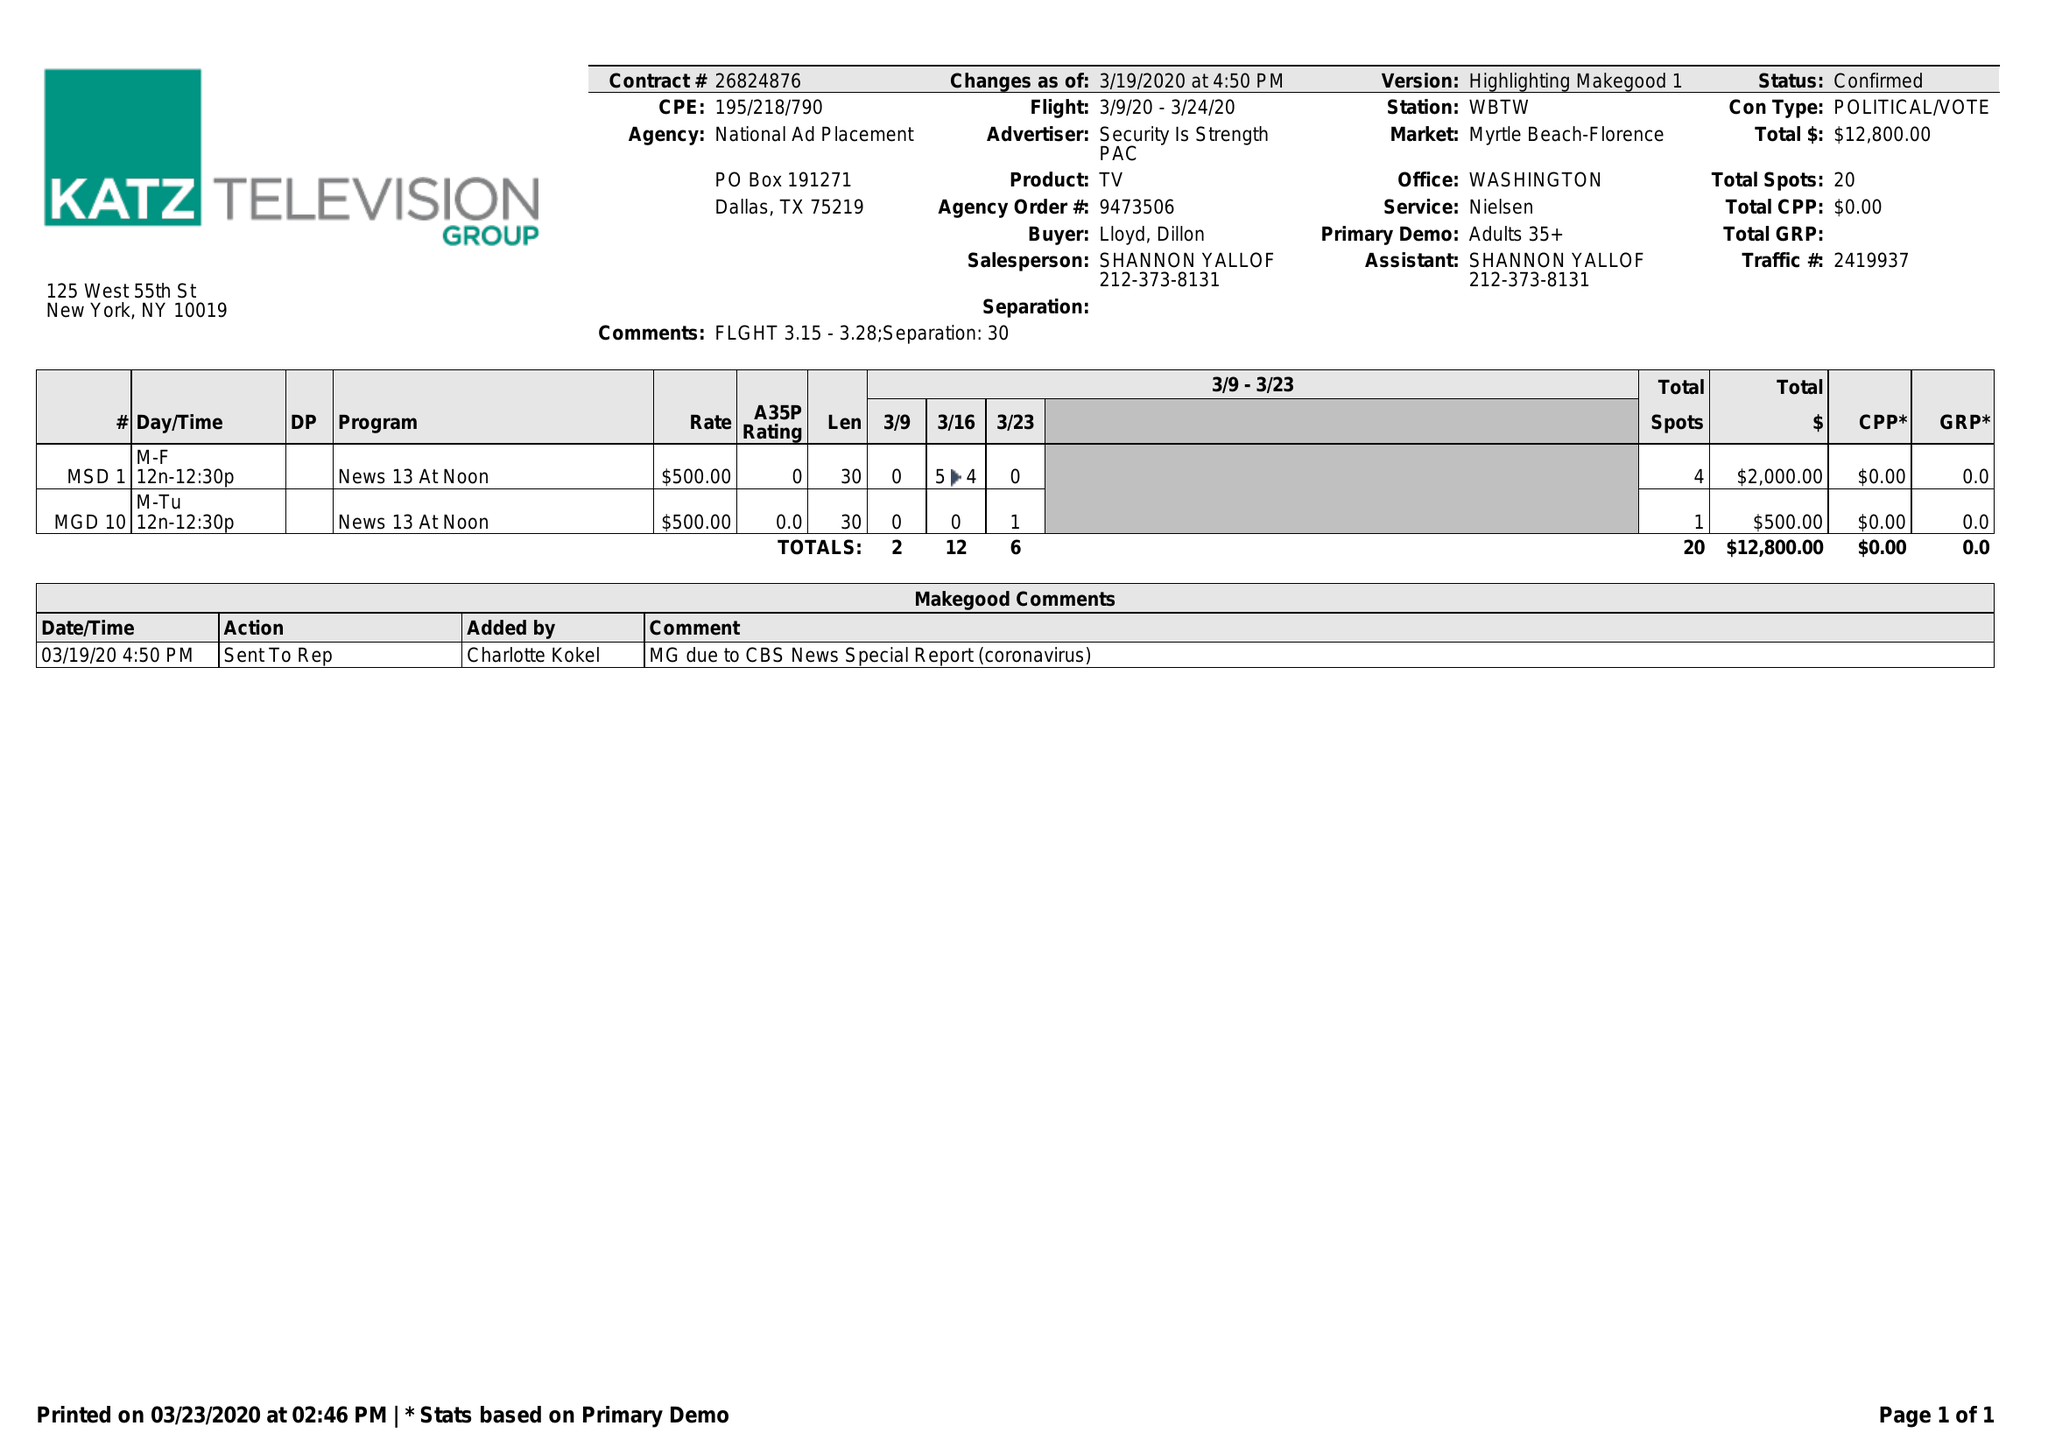What is the value for the contract_num?
Answer the question using a single word or phrase. 26824876 